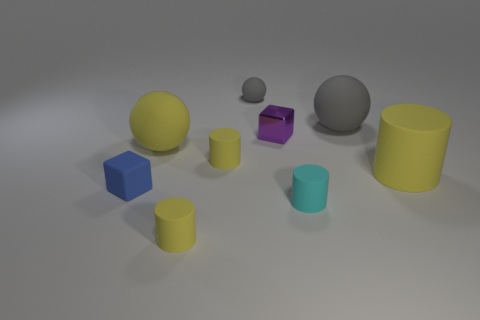Subtract all big balls. How many balls are left? 1 Subtract all cyan cylinders. How many cylinders are left? 3 Subtract 2 cubes. How many cubes are left? 0 Subtract all spheres. How many objects are left? 6 Subtract 0 purple cylinders. How many objects are left? 9 Subtract all green cylinders. Subtract all cyan spheres. How many cylinders are left? 4 Subtract all brown cylinders. How many purple cubes are left? 1 Subtract all big gray matte balls. Subtract all cylinders. How many objects are left? 4 Add 1 small gray balls. How many small gray balls are left? 2 Add 7 tiny yellow objects. How many tiny yellow objects exist? 9 